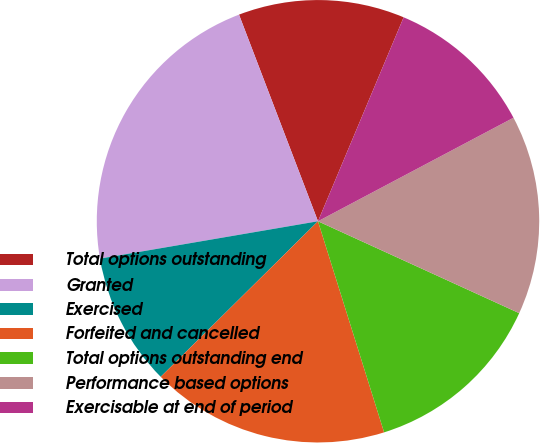Convert chart to OTSL. <chart><loc_0><loc_0><loc_500><loc_500><pie_chart><fcel>Total options outstanding<fcel>Granted<fcel>Exercised<fcel>Forfeited and cancelled<fcel>Total options outstanding end<fcel>Performance based options<fcel>Exercisable at end of period<nl><fcel>12.14%<fcel>21.89%<fcel>9.71%<fcel>17.42%<fcel>13.35%<fcel>14.57%<fcel>10.92%<nl></chart> 